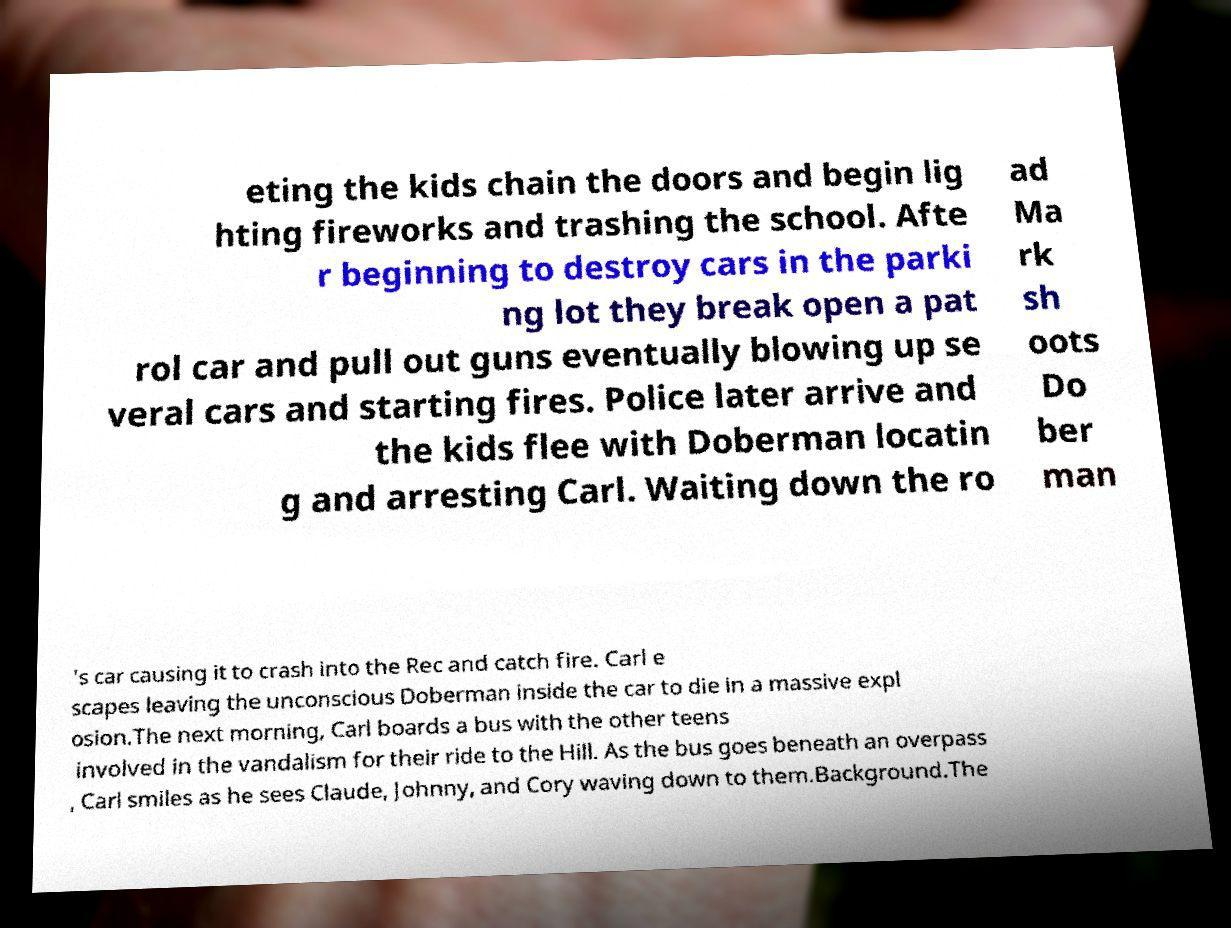Can you read and provide the text displayed in the image?This photo seems to have some interesting text. Can you extract and type it out for me? eting the kids chain the doors and begin lig hting fireworks and trashing the school. Afte r beginning to destroy cars in the parki ng lot they break open a pat rol car and pull out guns eventually blowing up se veral cars and starting fires. Police later arrive and the kids flee with Doberman locatin g and arresting Carl. Waiting down the ro ad Ma rk sh oots Do ber man 's car causing it to crash into the Rec and catch fire. Carl e scapes leaving the unconscious Doberman inside the car to die in a massive expl osion.The next morning, Carl boards a bus with the other teens involved in the vandalism for their ride to the Hill. As the bus goes beneath an overpass , Carl smiles as he sees Claude, Johnny, and Cory waving down to them.Background.The 